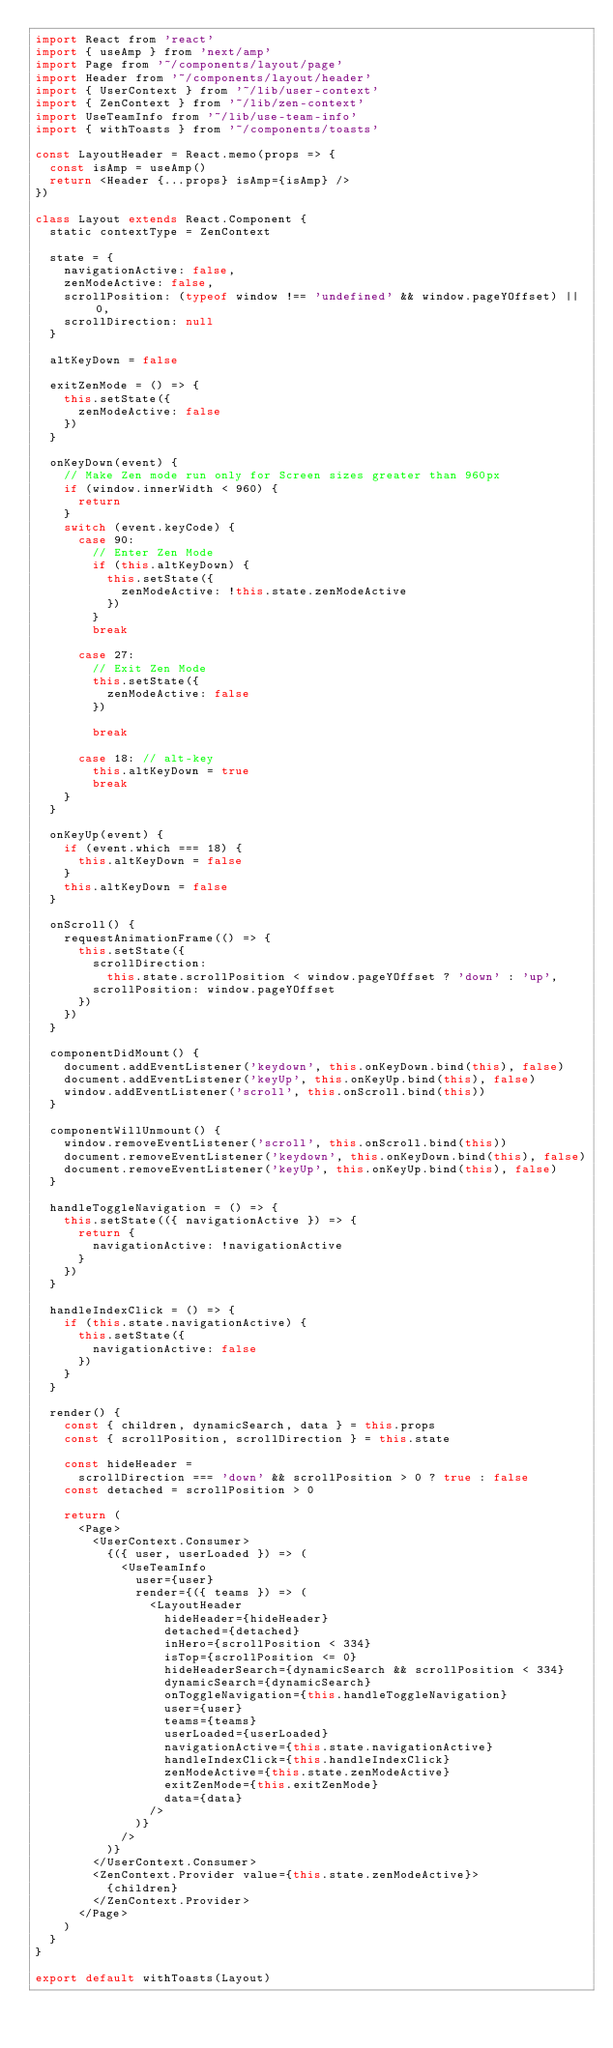<code> <loc_0><loc_0><loc_500><loc_500><_JavaScript_>import React from 'react'
import { useAmp } from 'next/amp'
import Page from '~/components/layout/page'
import Header from '~/components/layout/header'
import { UserContext } from '~/lib/user-context'
import { ZenContext } from '~/lib/zen-context'
import UseTeamInfo from '~/lib/use-team-info'
import { withToasts } from '~/components/toasts'

const LayoutHeader = React.memo(props => {
  const isAmp = useAmp()
  return <Header {...props} isAmp={isAmp} />
})

class Layout extends React.Component {
  static contextType = ZenContext

  state = {
    navigationActive: false,
    zenModeActive: false,
    scrollPosition: (typeof window !== 'undefined' && window.pageYOffset) || 0,
    scrollDirection: null
  }

  altKeyDown = false

  exitZenMode = () => {
    this.setState({
      zenModeActive: false
    })
  }

  onKeyDown(event) {
    // Make Zen mode run only for Screen sizes greater than 960px
    if (window.innerWidth < 960) {
      return
    }
    switch (event.keyCode) {
      case 90:
        // Enter Zen Mode
        if (this.altKeyDown) {
          this.setState({
            zenModeActive: !this.state.zenModeActive
          })
        }
        break

      case 27:
        // Exit Zen Mode
        this.setState({
          zenModeActive: false
        })

        break

      case 18: // alt-key
        this.altKeyDown = true
        break
    }
  }

  onKeyUp(event) {
    if (event.which === 18) {
      this.altKeyDown = false
    }
    this.altKeyDown = false
  }

  onScroll() {
    requestAnimationFrame(() => {
      this.setState({
        scrollDirection:
          this.state.scrollPosition < window.pageYOffset ? 'down' : 'up',
        scrollPosition: window.pageYOffset
      })
    })
  }

  componentDidMount() {
    document.addEventListener('keydown', this.onKeyDown.bind(this), false)
    document.addEventListener('keyUp', this.onKeyUp.bind(this), false)
    window.addEventListener('scroll', this.onScroll.bind(this))
  }

  componentWillUnmount() {
    window.removeEventListener('scroll', this.onScroll.bind(this))
    document.removeEventListener('keydown', this.onKeyDown.bind(this), false)
    document.removeEventListener('keyUp', this.onKeyUp.bind(this), false)
  }

  handleToggleNavigation = () => {
    this.setState(({ navigationActive }) => {
      return {
        navigationActive: !navigationActive
      }
    })
  }

  handleIndexClick = () => {
    if (this.state.navigationActive) {
      this.setState({
        navigationActive: false
      })
    }
  }

  render() {
    const { children, dynamicSearch, data } = this.props
    const { scrollPosition, scrollDirection } = this.state

    const hideHeader =
      scrollDirection === 'down' && scrollPosition > 0 ? true : false
    const detached = scrollPosition > 0

    return (
      <Page>
        <UserContext.Consumer>
          {({ user, userLoaded }) => (
            <UseTeamInfo
              user={user}
              render={({ teams }) => (
                <LayoutHeader
                  hideHeader={hideHeader}
                  detached={detached}
                  inHero={scrollPosition < 334}
                  isTop={scrollPosition <= 0}
                  hideHeaderSearch={dynamicSearch && scrollPosition < 334}
                  dynamicSearch={dynamicSearch}
                  onToggleNavigation={this.handleToggleNavigation}
                  user={user}
                  teams={teams}
                  userLoaded={userLoaded}
                  navigationActive={this.state.navigationActive}
                  handleIndexClick={this.handleIndexClick}
                  zenModeActive={this.state.zenModeActive}
                  exitZenMode={this.exitZenMode}
                  data={data}
                />
              )}
            />
          )}
        </UserContext.Consumer>
        <ZenContext.Provider value={this.state.zenModeActive}>
          {children}
        </ZenContext.Provider>
      </Page>
    )
  }
}

export default withToasts(Layout)
</code> 